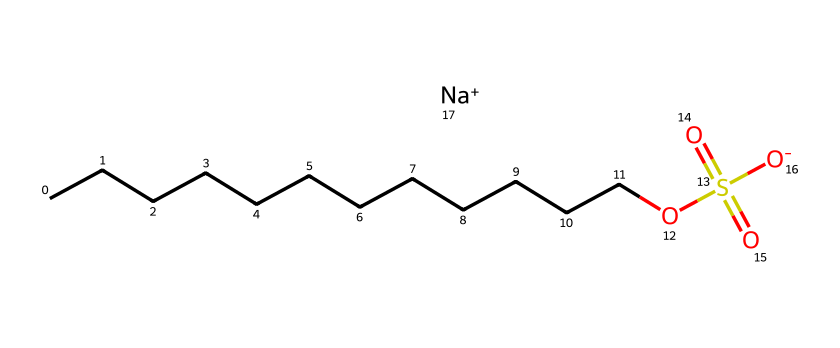What is the total number of carbon atoms in sodium lauryl sulfate? The chemical structure shows a long hydrocarbon chain, specifically representing lauryl, which is made up of 12 carbon atoms.
Answer: 12 What functional group can be identified in this chemical? The chemical contains a sulfonate group, which is seen as the -OS(=O)(=O)[O-] part of the structure, indicating it's a surfactant.
Answer: sulfonate How many oxygen atoms are present in sodium lauryl sulfate? In the given structure, there are four oxygen atoms depicted in the sulfonate group, as represented in -OS(=O)(=O)[O-].
Answer: 4 Which atom indicates its ionic nature in sodium lauryl sulfate? The presence of the sodium ion, represented by [Na+], signifies the ionic nature of this compound as it contains a charged particle.
Answer: sodium What type of surfactant is sodium lauryl sulfate classified as? Sodium lauryl sulfate falls into the category of anionic surfactants, which can be deduced from its negative charge due to the sulfonate group.
Answer: anionic What is the total number of sulfur atoms in sodium lauryl sulfate? The structure shows one sulfur atom in the sulfonate group, which is part of the -OS(=O)(=O)[O-] portion.
Answer: 1 What is the significance of the long carbon chain in sodium lauryl sulfate? The long carbon chain contributes to the hydrophobic properties of sodium lauryl sulfate, allowing it to interact with oils and greases for effective cleaning.
Answer: hydrophobic 